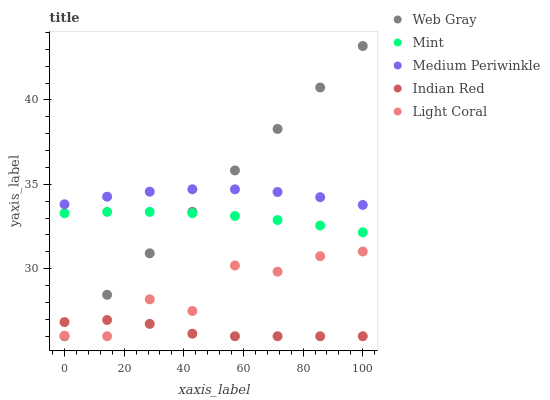Does Indian Red have the minimum area under the curve?
Answer yes or no. Yes. Does Web Gray have the maximum area under the curve?
Answer yes or no. Yes. Does Medium Periwinkle have the minimum area under the curve?
Answer yes or no. No. Does Medium Periwinkle have the maximum area under the curve?
Answer yes or no. No. Is Web Gray the smoothest?
Answer yes or no. Yes. Is Light Coral the roughest?
Answer yes or no. Yes. Is Medium Periwinkle the smoothest?
Answer yes or no. No. Is Medium Periwinkle the roughest?
Answer yes or no. No. Does Light Coral have the lowest value?
Answer yes or no. Yes. Does Medium Periwinkle have the lowest value?
Answer yes or no. No. Does Web Gray have the highest value?
Answer yes or no. Yes. Does Medium Periwinkle have the highest value?
Answer yes or no. No. Is Mint less than Medium Periwinkle?
Answer yes or no. Yes. Is Medium Periwinkle greater than Indian Red?
Answer yes or no. Yes. Does Web Gray intersect Indian Red?
Answer yes or no. Yes. Is Web Gray less than Indian Red?
Answer yes or no. No. Is Web Gray greater than Indian Red?
Answer yes or no. No. Does Mint intersect Medium Periwinkle?
Answer yes or no. No. 